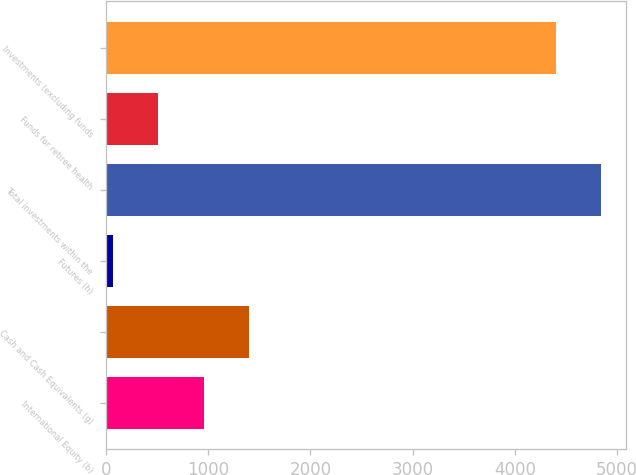Convert chart. <chart><loc_0><loc_0><loc_500><loc_500><bar_chart><fcel>International Equity (b)<fcel>Cash and Cash Equivalents (g)<fcel>Futures (h)<fcel>Total investments within the<fcel>Funds for retiree health<fcel>Investments (excluding funds<nl><fcel>955.6<fcel>1399.4<fcel>68<fcel>4844.8<fcel>511.8<fcel>4401<nl></chart> 